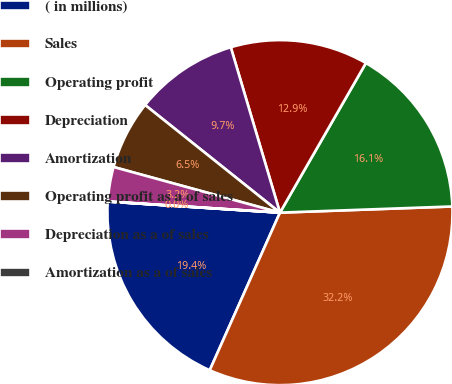Convert chart. <chart><loc_0><loc_0><loc_500><loc_500><pie_chart><fcel>( in millions)<fcel>Sales<fcel>Operating profit<fcel>Depreciation<fcel>Amortization<fcel>Operating profit as a of sales<fcel>Depreciation as a of sales<fcel>Amortization as a of sales<nl><fcel>19.35%<fcel>32.24%<fcel>16.13%<fcel>12.9%<fcel>9.68%<fcel>6.46%<fcel>3.23%<fcel>0.01%<nl></chart> 